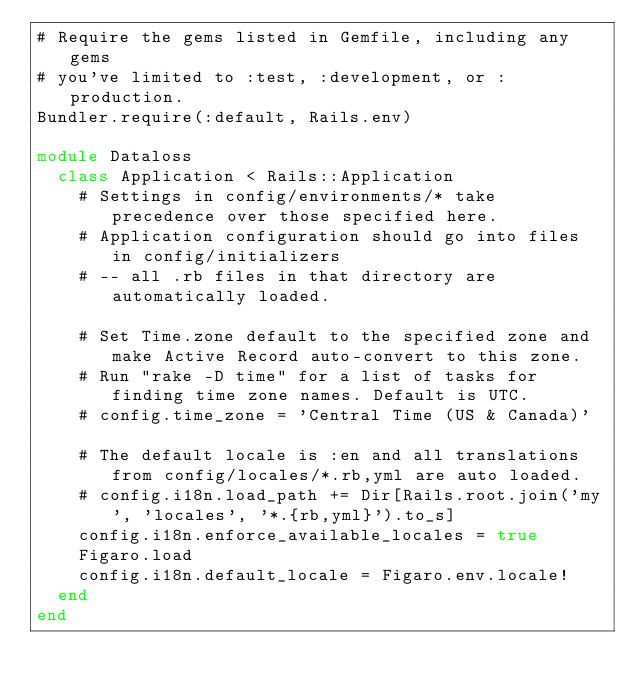<code> <loc_0><loc_0><loc_500><loc_500><_Ruby_># Require the gems listed in Gemfile, including any gems
# you've limited to :test, :development, or :production.
Bundler.require(:default, Rails.env)

module Dataloss
  class Application < Rails::Application
    # Settings in config/environments/* take precedence over those specified here.
    # Application configuration should go into files in config/initializers
    # -- all .rb files in that directory are automatically loaded.

    # Set Time.zone default to the specified zone and make Active Record auto-convert to this zone.
    # Run "rake -D time" for a list of tasks for finding time zone names. Default is UTC.
    # config.time_zone = 'Central Time (US & Canada)'

    # The default locale is :en and all translations from config/locales/*.rb,yml are auto loaded.
    # config.i18n.load_path += Dir[Rails.root.join('my', 'locales', '*.{rb,yml}').to_s]
    config.i18n.enforce_available_locales = true
    Figaro.load
    config.i18n.default_locale = Figaro.env.locale!
  end
end
</code> 